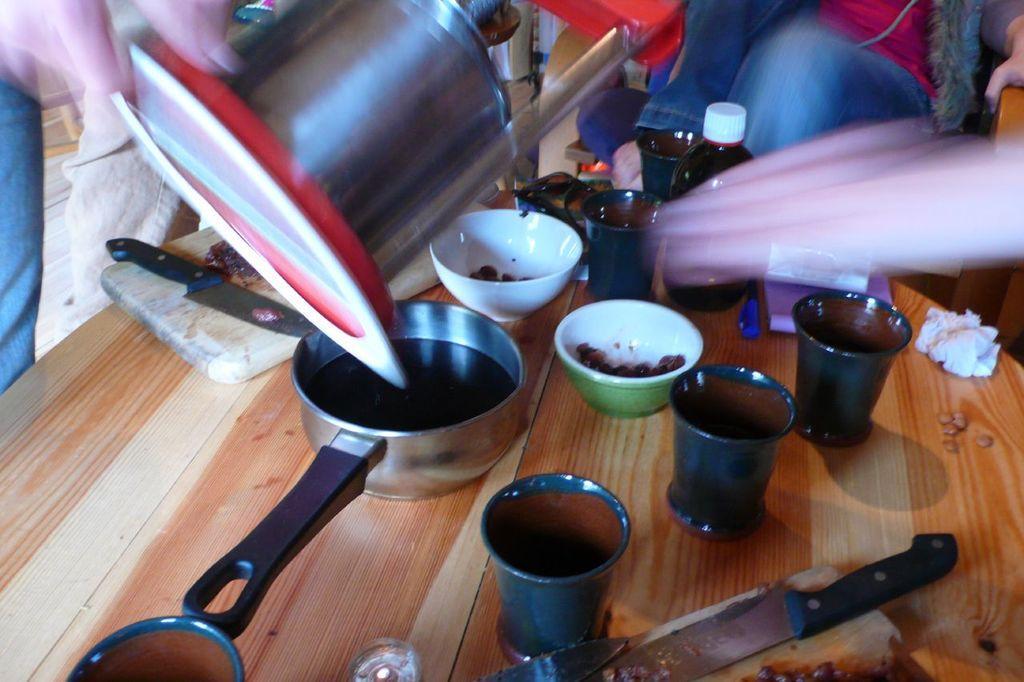Describe this image in one or two sentences. In this image we can see a wooden surface. On that there are glasses, knives, paper, pen, bottle, bowls with food item, pan with some item, cutting table and many other things. On the cutting table there is a knife. We can see a person holding something. In the back there is another person. 